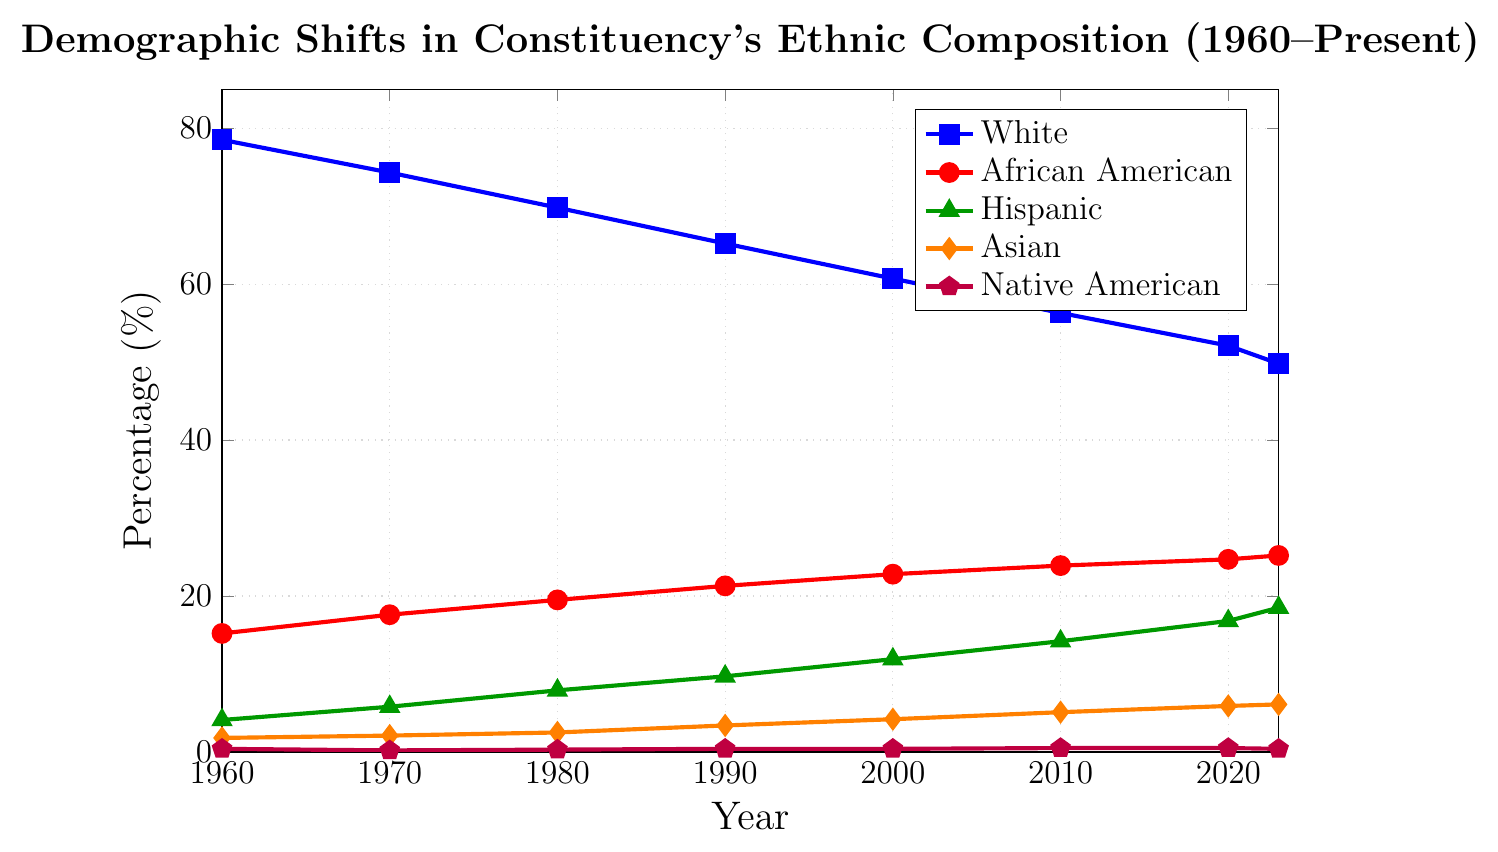What percentage of the population was Hispanic in 1980 and 2020, and what is the difference? In 1980, the Hispanic population was 7.9%, and in 2020, it was 16.8%. The difference is 16.8% - 7.9%.
Answer: 8.9% Which ethnic group saw the largest decrease in percentage from 1960 to the present? By comparing the percentage points of each group from 1960 to the present, we see that the White group decreased from 78.5% to 49.8%, a change of 28.7%, which is the largest decrease.
Answer: White Between 1960 and the present, which two ethnic groups showed the most increase in their percentage values? By examining the changes from 1960 to the present, the Hispanic group increased from 4.1% to 18.5%, and the Asian group increased from 1.8% to 6.1%. The Hispanic and Asian groups showed the most increase.
Answer: Hispanic and Asian What is the combined percentage of African American and Hispanic populations in 2000? The African American population in 2000 was 22.8%, and the Hispanic population was 11.9%. Adding these together gives 22.8% + 11.9% = 34.7%.
Answer: 34.7% How did the Native American population percentage change from 1960 to the present? The Native American population was 0.4% in 1960 and 0.4% at present, showing no change.
Answer: No change Which year showed the largest growth in the African American population compared to the previous decade? By comparing the growth rates of the African American population across the decades, the growth from 1960 (15.2%) to 1970 (17.6%) was 2.4%, 1970 to 1980 was 1.9%, 1980 to 1990 was 1.8%, 1990 to 2000 was 1.5%, 2000 to 2010 was 1.1%, and 2010 to 2020 was 0.8%. The largest growth occurred between 1960 and 1970 at 2.4%.
Answer: 1960 to 1970 In which decade did the Hispanic population percentage surpass the Asian population percentage? By examining the plot, the Hispanic population surpassed the Asian population percentage between 1960 and 1970, as it increased from 4.1% to 5.8%, while the Asian population went from 1.8% to 2.1%.
Answer: 1960 to 1970 What is the visual pattern or trend seen in the White population from 1960 to the present? The line for the White population shows a clear downward trend, decreasing steadily from 78.5% in 1960 to 49.8% in the present.
Answer: Downward trend Which ethnic group had the smallest percentage point change from 1960 to the present? By comparing percentage point changes for each group from 1960 to the present: White (28.7% decrease), African American (10% increase), Hispanic (14.4% increase), Asian (4.3% increase), Native American (no change). Native American had the smallest change.
Answer: Native American 